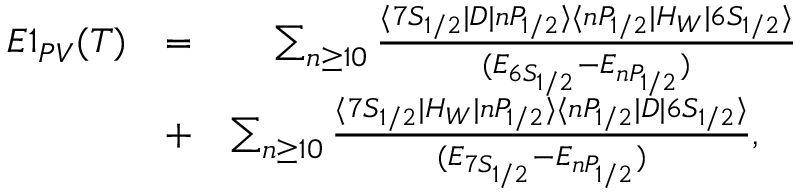Convert formula to latex. <formula><loc_0><loc_0><loc_500><loc_500>\begin{array} { r l r } { E 1 _ { P V } ( T ) } & { = } & { \sum _ { n \geq 1 0 } \frac { \langle 7 S _ { 1 / 2 } | D | n P _ { 1 / 2 } \rangle \langle n P _ { 1 / 2 } | H _ { W } | 6 S _ { 1 / 2 } \rangle } { ( E _ { 6 S _ { 1 / 2 } } - E _ { n P _ { 1 / 2 } } ) } } \\ & { + } & { \sum _ { n \geq 1 0 } \frac { \langle 7 S _ { 1 / 2 } | H _ { W } | n P _ { 1 / 2 } \rangle \langle n P _ { 1 / 2 } | D | 6 S _ { 1 / 2 } \rangle } { ( E _ { 7 S _ { 1 / 2 } } - E _ { n P _ { 1 / 2 } } ) } , \quad } \end{array}</formula> 